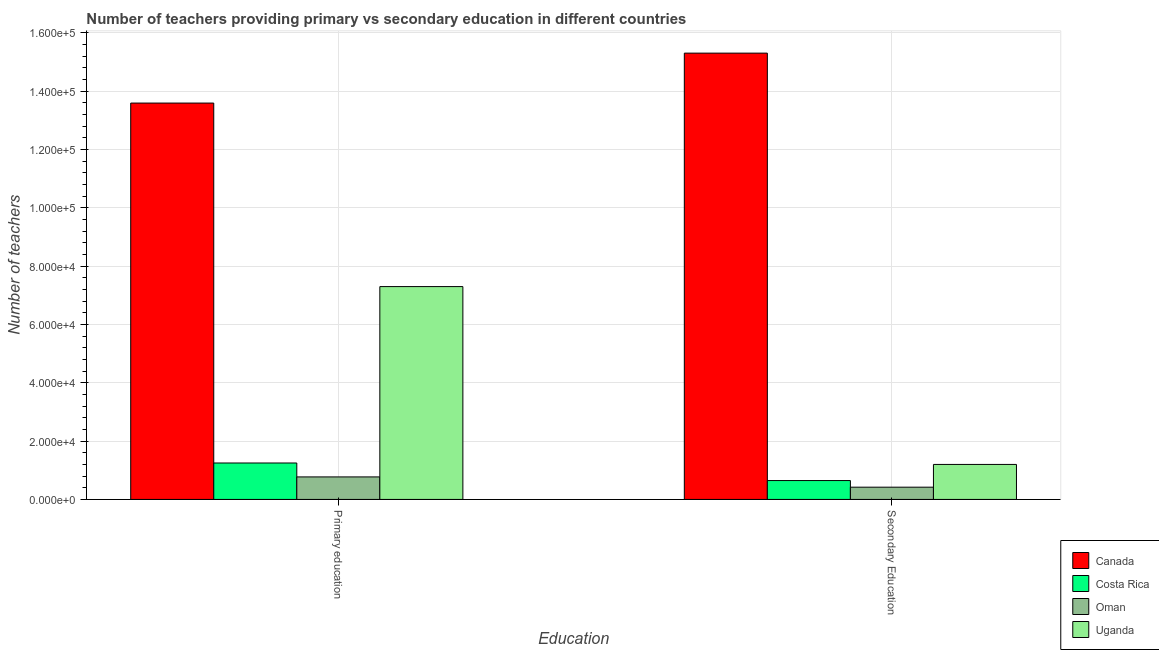How many different coloured bars are there?
Keep it short and to the point. 4. How many groups of bars are there?
Your answer should be compact. 2. Are the number of bars per tick equal to the number of legend labels?
Your response must be concise. Yes. How many bars are there on the 2nd tick from the left?
Provide a succinct answer. 4. How many bars are there on the 2nd tick from the right?
Your response must be concise. 4. What is the label of the 2nd group of bars from the left?
Your answer should be compact. Secondary Education. What is the number of secondary teachers in Canada?
Offer a terse response. 1.53e+05. Across all countries, what is the maximum number of secondary teachers?
Make the answer very short. 1.53e+05. Across all countries, what is the minimum number of primary teachers?
Offer a very short reply. 7716. In which country was the number of secondary teachers minimum?
Provide a succinct answer. Oman. What is the total number of secondary teachers in the graph?
Provide a succinct answer. 1.76e+05. What is the difference between the number of secondary teachers in Canada and that in Oman?
Provide a succinct answer. 1.49e+05. What is the difference between the number of secondary teachers in Uganda and the number of primary teachers in Costa Rica?
Your response must be concise. -490. What is the average number of primary teachers per country?
Offer a very short reply. 5.73e+04. What is the difference between the number of primary teachers and number of secondary teachers in Oman?
Offer a very short reply. 3520. In how many countries, is the number of primary teachers greater than 156000 ?
Give a very brief answer. 0. What is the ratio of the number of primary teachers in Uganda to that in Oman?
Your answer should be very brief. 9.46. What does the 4th bar from the left in Primary education represents?
Ensure brevity in your answer.  Uganda. How many bars are there?
Offer a terse response. 8. What is the difference between two consecutive major ticks on the Y-axis?
Make the answer very short. 2.00e+04. Are the values on the major ticks of Y-axis written in scientific E-notation?
Provide a short and direct response. Yes. Does the graph contain any zero values?
Provide a short and direct response. No. Where does the legend appear in the graph?
Offer a very short reply. Bottom right. How are the legend labels stacked?
Provide a short and direct response. Vertical. What is the title of the graph?
Provide a short and direct response. Number of teachers providing primary vs secondary education in different countries. Does "Cyprus" appear as one of the legend labels in the graph?
Give a very brief answer. No. What is the label or title of the X-axis?
Keep it short and to the point. Education. What is the label or title of the Y-axis?
Give a very brief answer. Number of teachers. What is the Number of teachers in Canada in Primary education?
Offer a very short reply. 1.36e+05. What is the Number of teachers in Costa Rica in Primary education?
Your answer should be very brief. 1.25e+04. What is the Number of teachers of Oman in Primary education?
Make the answer very short. 7716. What is the Number of teachers in Uganda in Primary education?
Ensure brevity in your answer.  7.30e+04. What is the Number of teachers in Canada in Secondary Education?
Make the answer very short. 1.53e+05. What is the Number of teachers of Costa Rica in Secondary Education?
Your response must be concise. 6472. What is the Number of teachers in Oman in Secondary Education?
Keep it short and to the point. 4196. What is the Number of teachers of Uganda in Secondary Education?
Your answer should be compact. 1.20e+04. Across all Education, what is the maximum Number of teachers in Canada?
Give a very brief answer. 1.53e+05. Across all Education, what is the maximum Number of teachers in Costa Rica?
Provide a succinct answer. 1.25e+04. Across all Education, what is the maximum Number of teachers in Oman?
Provide a succinct answer. 7716. Across all Education, what is the maximum Number of teachers in Uganda?
Offer a very short reply. 7.30e+04. Across all Education, what is the minimum Number of teachers of Canada?
Your response must be concise. 1.36e+05. Across all Education, what is the minimum Number of teachers in Costa Rica?
Your answer should be very brief. 6472. Across all Education, what is the minimum Number of teachers in Oman?
Make the answer very short. 4196. Across all Education, what is the minimum Number of teachers in Uganda?
Provide a short and direct response. 1.20e+04. What is the total Number of teachers of Canada in the graph?
Keep it short and to the point. 2.89e+05. What is the total Number of teachers of Costa Rica in the graph?
Give a very brief answer. 1.90e+04. What is the total Number of teachers in Oman in the graph?
Offer a terse response. 1.19e+04. What is the total Number of teachers of Uganda in the graph?
Your answer should be very brief. 8.50e+04. What is the difference between the Number of teachers in Canada in Primary education and that in Secondary Education?
Your answer should be compact. -1.71e+04. What is the difference between the Number of teachers in Costa Rica in Primary education and that in Secondary Education?
Provide a succinct answer. 6018. What is the difference between the Number of teachers in Oman in Primary education and that in Secondary Education?
Offer a terse response. 3520. What is the difference between the Number of teachers in Uganda in Primary education and that in Secondary Education?
Provide a succinct answer. 6.10e+04. What is the difference between the Number of teachers of Canada in Primary education and the Number of teachers of Costa Rica in Secondary Education?
Provide a succinct answer. 1.29e+05. What is the difference between the Number of teachers in Canada in Primary education and the Number of teachers in Oman in Secondary Education?
Provide a short and direct response. 1.32e+05. What is the difference between the Number of teachers of Canada in Primary education and the Number of teachers of Uganda in Secondary Education?
Offer a terse response. 1.24e+05. What is the difference between the Number of teachers in Costa Rica in Primary education and the Number of teachers in Oman in Secondary Education?
Offer a very short reply. 8294. What is the difference between the Number of teachers of Costa Rica in Primary education and the Number of teachers of Uganda in Secondary Education?
Make the answer very short. 490. What is the difference between the Number of teachers of Oman in Primary education and the Number of teachers of Uganda in Secondary Education?
Your response must be concise. -4284. What is the average Number of teachers of Canada per Education?
Provide a short and direct response. 1.44e+05. What is the average Number of teachers in Costa Rica per Education?
Your answer should be compact. 9481. What is the average Number of teachers in Oman per Education?
Your response must be concise. 5956. What is the average Number of teachers in Uganda per Education?
Keep it short and to the point. 4.25e+04. What is the difference between the Number of teachers in Canada and Number of teachers in Costa Rica in Primary education?
Give a very brief answer. 1.23e+05. What is the difference between the Number of teachers of Canada and Number of teachers of Oman in Primary education?
Your answer should be compact. 1.28e+05. What is the difference between the Number of teachers of Canada and Number of teachers of Uganda in Primary education?
Ensure brevity in your answer.  6.29e+04. What is the difference between the Number of teachers of Costa Rica and Number of teachers of Oman in Primary education?
Make the answer very short. 4774. What is the difference between the Number of teachers in Costa Rica and Number of teachers in Uganda in Primary education?
Provide a short and direct response. -6.05e+04. What is the difference between the Number of teachers in Oman and Number of teachers in Uganda in Primary education?
Your response must be concise. -6.53e+04. What is the difference between the Number of teachers in Canada and Number of teachers in Costa Rica in Secondary Education?
Keep it short and to the point. 1.47e+05. What is the difference between the Number of teachers in Canada and Number of teachers in Oman in Secondary Education?
Ensure brevity in your answer.  1.49e+05. What is the difference between the Number of teachers in Canada and Number of teachers in Uganda in Secondary Education?
Make the answer very short. 1.41e+05. What is the difference between the Number of teachers in Costa Rica and Number of teachers in Oman in Secondary Education?
Your answer should be very brief. 2276. What is the difference between the Number of teachers of Costa Rica and Number of teachers of Uganda in Secondary Education?
Offer a very short reply. -5528. What is the difference between the Number of teachers of Oman and Number of teachers of Uganda in Secondary Education?
Ensure brevity in your answer.  -7804. What is the ratio of the Number of teachers of Canada in Primary education to that in Secondary Education?
Your answer should be very brief. 0.89. What is the ratio of the Number of teachers in Costa Rica in Primary education to that in Secondary Education?
Ensure brevity in your answer.  1.93. What is the ratio of the Number of teachers in Oman in Primary education to that in Secondary Education?
Provide a succinct answer. 1.84. What is the ratio of the Number of teachers in Uganda in Primary education to that in Secondary Education?
Offer a very short reply. 6.08. What is the difference between the highest and the second highest Number of teachers in Canada?
Give a very brief answer. 1.71e+04. What is the difference between the highest and the second highest Number of teachers in Costa Rica?
Offer a very short reply. 6018. What is the difference between the highest and the second highest Number of teachers in Oman?
Your answer should be very brief. 3520. What is the difference between the highest and the second highest Number of teachers in Uganda?
Offer a very short reply. 6.10e+04. What is the difference between the highest and the lowest Number of teachers in Canada?
Ensure brevity in your answer.  1.71e+04. What is the difference between the highest and the lowest Number of teachers in Costa Rica?
Provide a succinct answer. 6018. What is the difference between the highest and the lowest Number of teachers of Oman?
Provide a succinct answer. 3520. What is the difference between the highest and the lowest Number of teachers of Uganda?
Provide a succinct answer. 6.10e+04. 